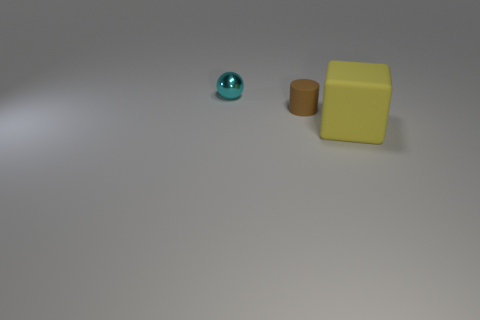Add 1 rubber cylinders. How many objects exist? 4 Subtract all spheres. How many objects are left? 2 Subtract 0 cyan blocks. How many objects are left? 3 Subtract 1 balls. How many balls are left? 0 Subtract all purple spheres. Subtract all yellow blocks. How many spheres are left? 1 Subtract all gray balls. How many blue cubes are left? 0 Subtract all blue metallic cubes. Subtract all yellow matte cubes. How many objects are left? 2 Add 1 cyan objects. How many cyan objects are left? 2 Add 2 blocks. How many blocks exist? 3 